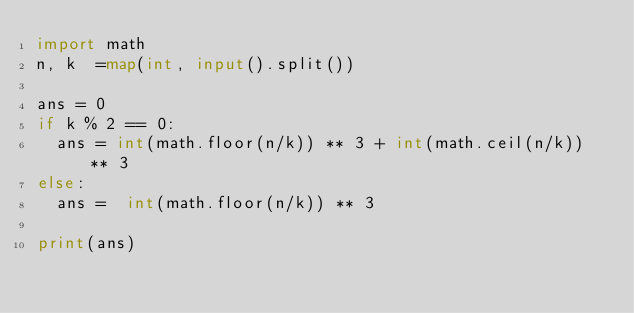<code> <loc_0><loc_0><loc_500><loc_500><_Python_>import math
n, k  =map(int, input().split())

ans = 0
if k % 2 == 0:
  ans = int(math.floor(n/k)) ** 3 + int(math.ceil(n/k)) ** 3
else:
  ans =  int(math.floor(n/k)) ** 3
  
print(ans)</code> 